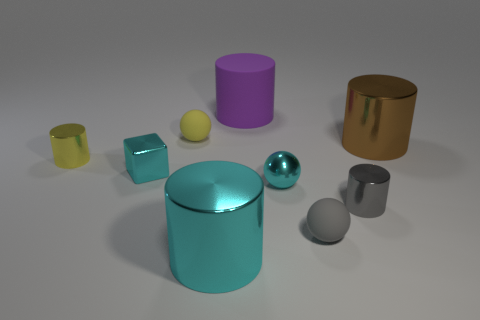Subtract all yellow cylinders. How many cylinders are left? 4 Subtract all green cubes. Subtract all gray spheres. How many cubes are left? 1 Add 1 large objects. How many objects exist? 10 Subtract all cylinders. How many objects are left? 4 Add 6 purple things. How many purple things are left? 7 Add 6 blue blocks. How many blue blocks exist? 6 Subtract 0 red blocks. How many objects are left? 9 Subtract all small cyan cubes. Subtract all tiny cyan metal cubes. How many objects are left? 7 